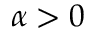Convert formula to latex. <formula><loc_0><loc_0><loc_500><loc_500>\alpha > 0</formula> 